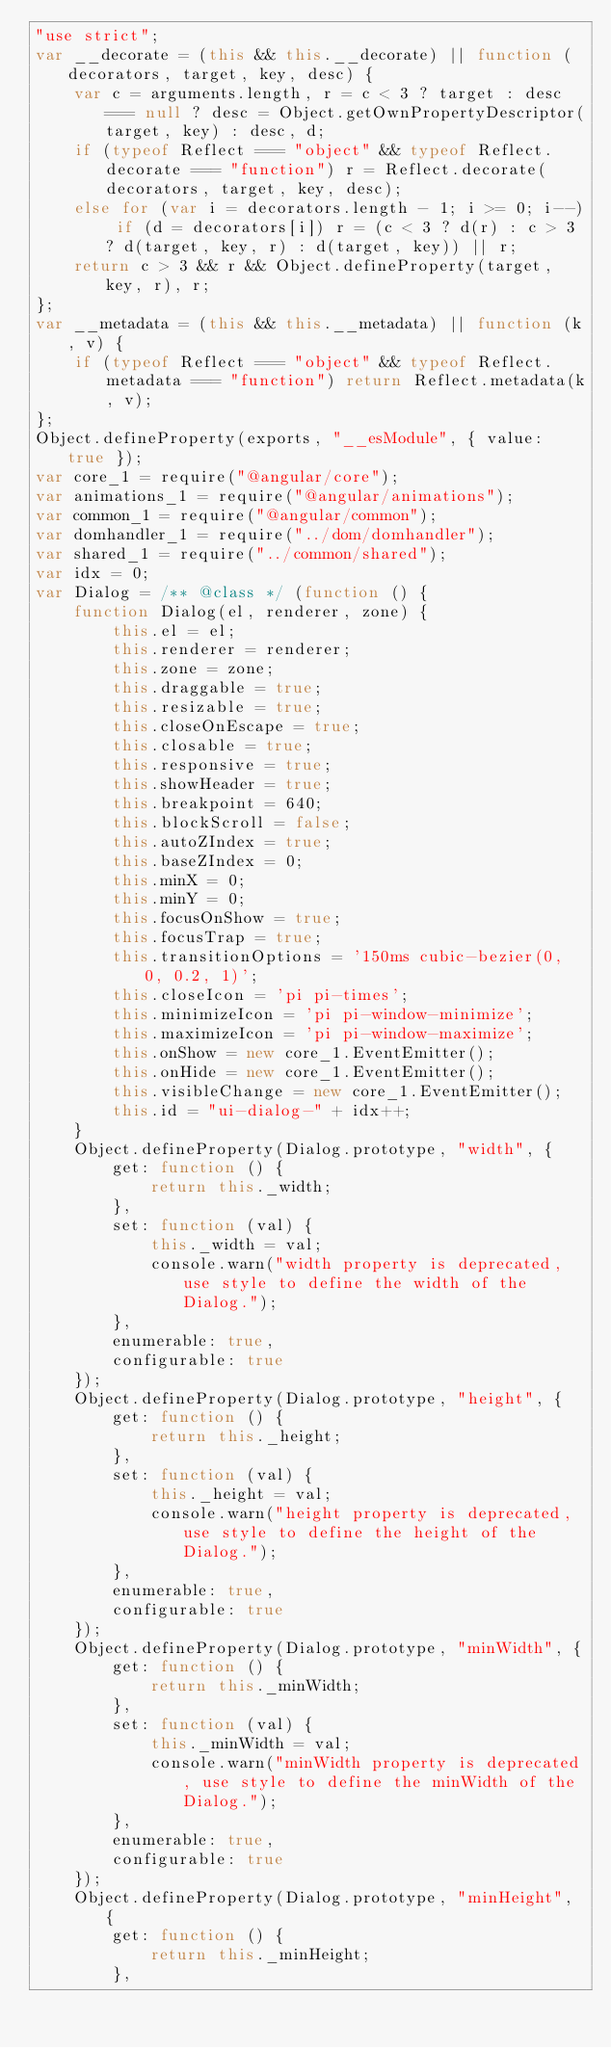Convert code to text. <code><loc_0><loc_0><loc_500><loc_500><_JavaScript_>"use strict";
var __decorate = (this && this.__decorate) || function (decorators, target, key, desc) {
    var c = arguments.length, r = c < 3 ? target : desc === null ? desc = Object.getOwnPropertyDescriptor(target, key) : desc, d;
    if (typeof Reflect === "object" && typeof Reflect.decorate === "function") r = Reflect.decorate(decorators, target, key, desc);
    else for (var i = decorators.length - 1; i >= 0; i--) if (d = decorators[i]) r = (c < 3 ? d(r) : c > 3 ? d(target, key, r) : d(target, key)) || r;
    return c > 3 && r && Object.defineProperty(target, key, r), r;
};
var __metadata = (this && this.__metadata) || function (k, v) {
    if (typeof Reflect === "object" && typeof Reflect.metadata === "function") return Reflect.metadata(k, v);
};
Object.defineProperty(exports, "__esModule", { value: true });
var core_1 = require("@angular/core");
var animations_1 = require("@angular/animations");
var common_1 = require("@angular/common");
var domhandler_1 = require("../dom/domhandler");
var shared_1 = require("../common/shared");
var idx = 0;
var Dialog = /** @class */ (function () {
    function Dialog(el, renderer, zone) {
        this.el = el;
        this.renderer = renderer;
        this.zone = zone;
        this.draggable = true;
        this.resizable = true;
        this.closeOnEscape = true;
        this.closable = true;
        this.responsive = true;
        this.showHeader = true;
        this.breakpoint = 640;
        this.blockScroll = false;
        this.autoZIndex = true;
        this.baseZIndex = 0;
        this.minX = 0;
        this.minY = 0;
        this.focusOnShow = true;
        this.focusTrap = true;
        this.transitionOptions = '150ms cubic-bezier(0, 0, 0.2, 1)';
        this.closeIcon = 'pi pi-times';
        this.minimizeIcon = 'pi pi-window-minimize';
        this.maximizeIcon = 'pi pi-window-maximize';
        this.onShow = new core_1.EventEmitter();
        this.onHide = new core_1.EventEmitter();
        this.visibleChange = new core_1.EventEmitter();
        this.id = "ui-dialog-" + idx++;
    }
    Object.defineProperty(Dialog.prototype, "width", {
        get: function () {
            return this._width;
        },
        set: function (val) {
            this._width = val;
            console.warn("width property is deprecated, use style to define the width of the Dialog.");
        },
        enumerable: true,
        configurable: true
    });
    Object.defineProperty(Dialog.prototype, "height", {
        get: function () {
            return this._height;
        },
        set: function (val) {
            this._height = val;
            console.warn("height property is deprecated, use style to define the height of the Dialog.");
        },
        enumerable: true,
        configurable: true
    });
    Object.defineProperty(Dialog.prototype, "minWidth", {
        get: function () {
            return this._minWidth;
        },
        set: function (val) {
            this._minWidth = val;
            console.warn("minWidth property is deprecated, use style to define the minWidth of the Dialog.");
        },
        enumerable: true,
        configurable: true
    });
    Object.defineProperty(Dialog.prototype, "minHeight", {
        get: function () {
            return this._minHeight;
        },</code> 